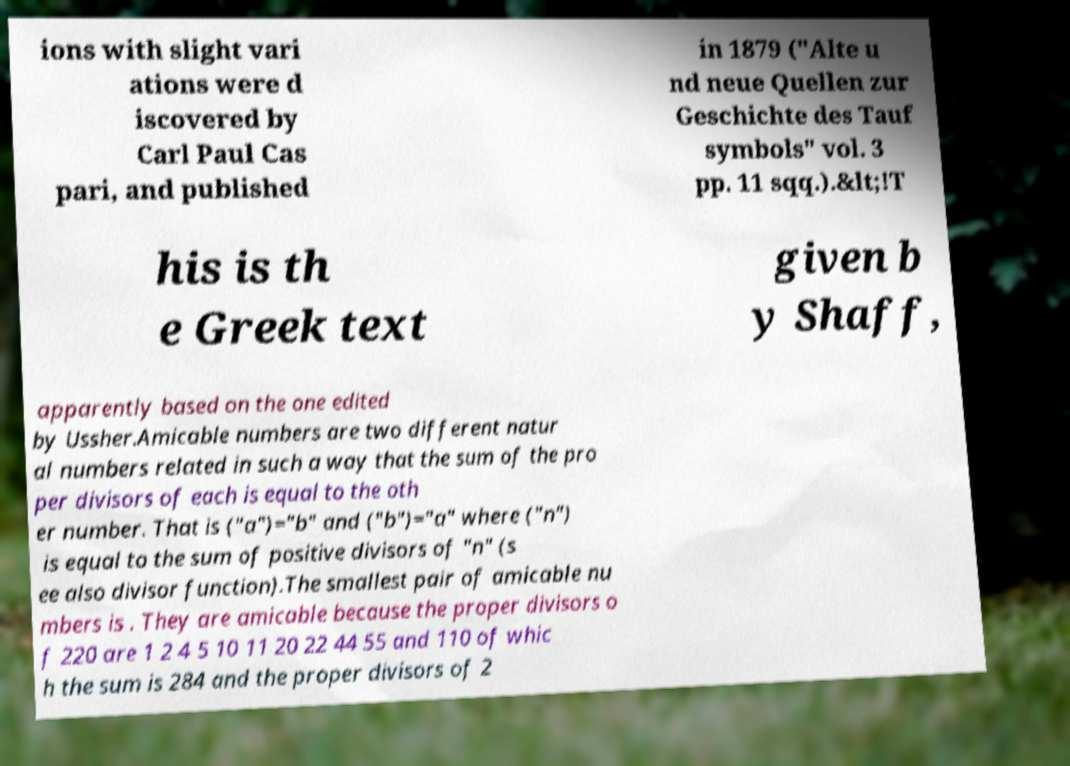I need the written content from this picture converted into text. Can you do that? ions with slight vari ations were d iscovered by Carl Paul Cas pari, and published in 1879 ("Alte u nd neue Quellen zur Geschichte des Tauf symbols" vol. 3 pp. 11 sqq.).&lt;!T his is th e Greek text given b y Shaff, apparently based on the one edited by Ussher.Amicable numbers are two different natur al numbers related in such a way that the sum of the pro per divisors of each is equal to the oth er number. That is ("a")="b" and ("b")="a" where ("n") is equal to the sum of positive divisors of "n" (s ee also divisor function).The smallest pair of amicable nu mbers is . They are amicable because the proper divisors o f 220 are 1 2 4 5 10 11 20 22 44 55 and 110 of whic h the sum is 284 and the proper divisors of 2 